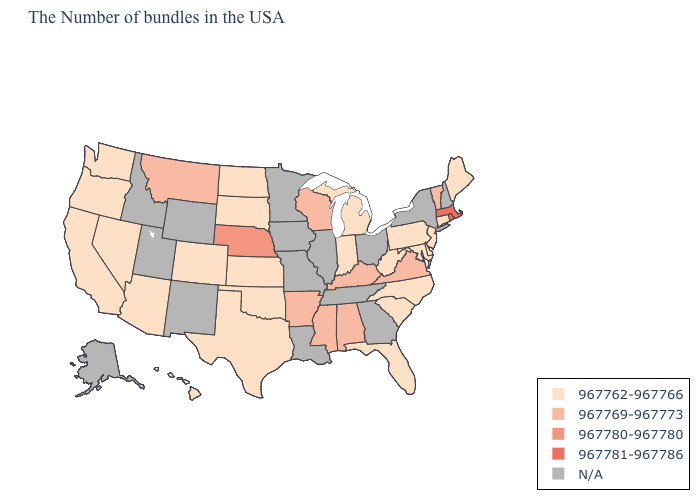What is the value of Louisiana?
Answer briefly. N/A. Is the legend a continuous bar?
Short answer required. No. Name the states that have a value in the range 967780-967780?
Quick response, please. Nebraska. What is the highest value in the MidWest ?
Concise answer only. 967780-967780. Name the states that have a value in the range 967762-967766?
Be succinct. Maine, Connecticut, New Jersey, Delaware, Maryland, Pennsylvania, North Carolina, South Carolina, West Virginia, Florida, Michigan, Indiana, Kansas, Oklahoma, Texas, South Dakota, North Dakota, Colorado, Arizona, Nevada, California, Washington, Oregon, Hawaii. Which states have the lowest value in the USA?
Answer briefly. Maine, Connecticut, New Jersey, Delaware, Maryland, Pennsylvania, North Carolina, South Carolina, West Virginia, Florida, Michigan, Indiana, Kansas, Oklahoma, Texas, South Dakota, North Dakota, Colorado, Arizona, Nevada, California, Washington, Oregon, Hawaii. Which states hav the highest value in the South?
Give a very brief answer. Virginia, Kentucky, Alabama, Mississippi, Arkansas. Among the states that border Florida , which have the highest value?
Quick response, please. Alabama. Which states have the lowest value in the USA?
Concise answer only. Maine, Connecticut, New Jersey, Delaware, Maryland, Pennsylvania, North Carolina, South Carolina, West Virginia, Florida, Michigan, Indiana, Kansas, Oklahoma, Texas, South Dakota, North Dakota, Colorado, Arizona, Nevada, California, Washington, Oregon, Hawaii. What is the lowest value in the USA?
Give a very brief answer. 967762-967766. What is the highest value in the USA?
Write a very short answer. 967781-967786. Name the states that have a value in the range 967781-967786?
Keep it brief. Massachusetts, Rhode Island. Does Michigan have the highest value in the MidWest?
Give a very brief answer. No. 